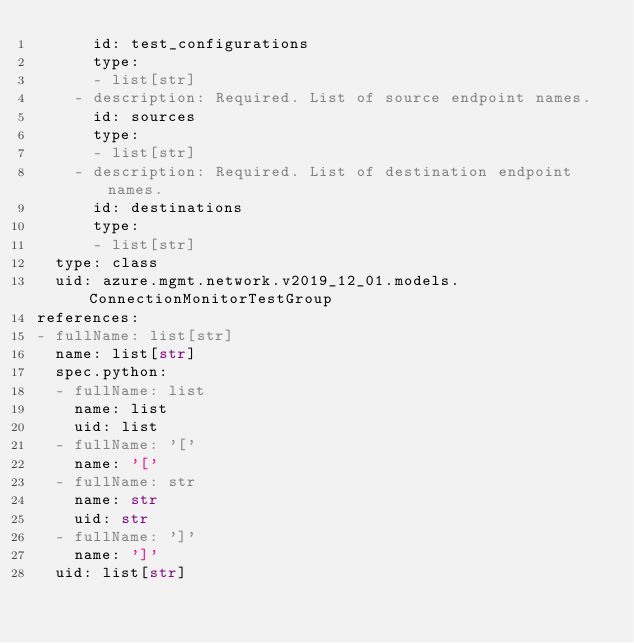Convert code to text. <code><loc_0><loc_0><loc_500><loc_500><_YAML_>      id: test_configurations
      type:
      - list[str]
    - description: Required. List of source endpoint names.
      id: sources
      type:
      - list[str]
    - description: Required. List of destination endpoint names.
      id: destinations
      type:
      - list[str]
  type: class
  uid: azure.mgmt.network.v2019_12_01.models.ConnectionMonitorTestGroup
references:
- fullName: list[str]
  name: list[str]
  spec.python:
  - fullName: list
    name: list
    uid: list
  - fullName: '['
    name: '['
  - fullName: str
    name: str
    uid: str
  - fullName: ']'
    name: ']'
  uid: list[str]
</code> 